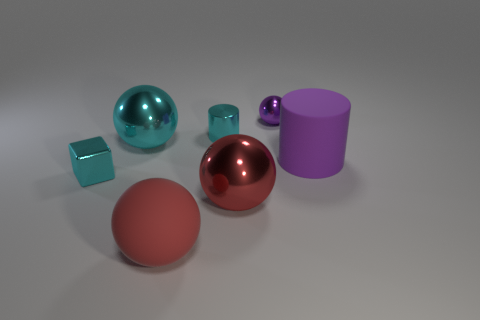Subtract all tiny purple metallic spheres. How many spheres are left? 3 Subtract all yellow balls. Subtract all green blocks. How many balls are left? 4 Add 3 purple matte things. How many objects exist? 10 Subtract all balls. How many objects are left? 3 Add 7 cyan shiny cylinders. How many cyan shiny cylinders exist? 8 Subtract 0 blue spheres. How many objects are left? 7 Subtract all big blue rubber objects. Subtract all large red balls. How many objects are left? 5 Add 6 big purple cylinders. How many big purple cylinders are left? 7 